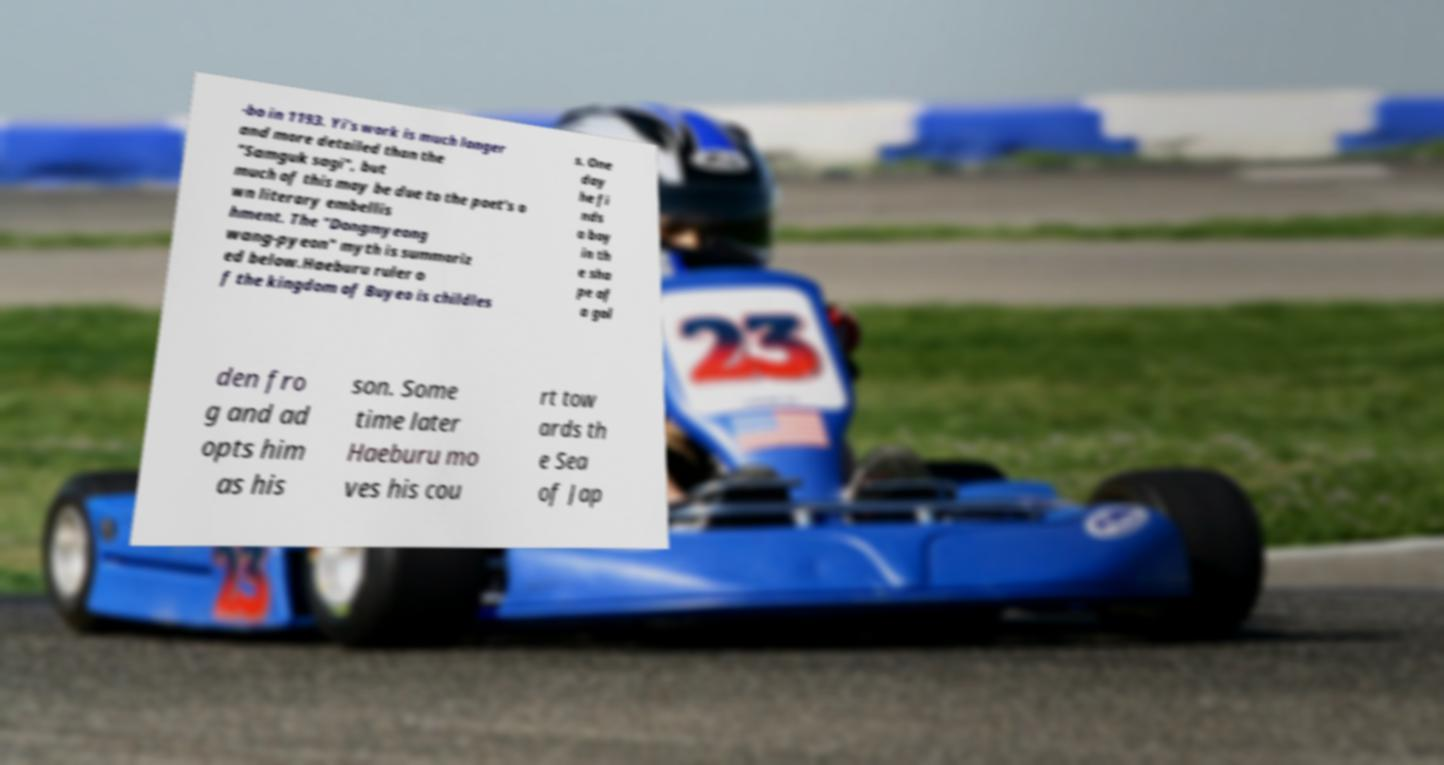Please read and relay the text visible in this image. What does it say? -bo in 1193. Yi's work is much longer and more detailed than the "Samguk sagi", but much of this may be due to the poet's o wn literary embellis hment. The "Dongmyeong wang-pyeon" myth is summariz ed below.Haeburu ruler o f the kingdom of Buyeo is childles s. One day he fi nds a boy in th e sha pe of a gol den fro g and ad opts him as his son. Some time later Haeburu mo ves his cou rt tow ards th e Sea of Jap 